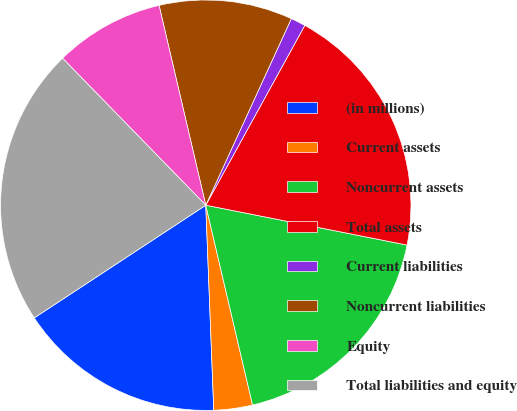<chart> <loc_0><loc_0><loc_500><loc_500><pie_chart><fcel>(in millions)<fcel>Current assets<fcel>Noncurrent assets<fcel>Total assets<fcel>Current liabilities<fcel>Noncurrent liabilities<fcel>Equity<fcel>Total liabilities and equity<nl><fcel>16.37%<fcel>3.04%<fcel>18.23%<fcel>20.1%<fcel>1.17%<fcel>10.5%<fcel>8.64%<fcel>21.96%<nl></chart> 